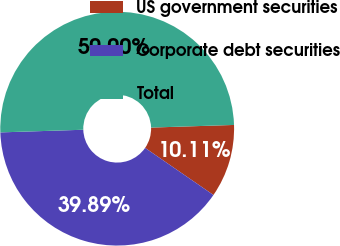Convert chart to OTSL. <chart><loc_0><loc_0><loc_500><loc_500><pie_chart><fcel>US government securities<fcel>Corporate debt securities<fcel>Total<nl><fcel>10.11%<fcel>39.89%<fcel>50.0%<nl></chart> 